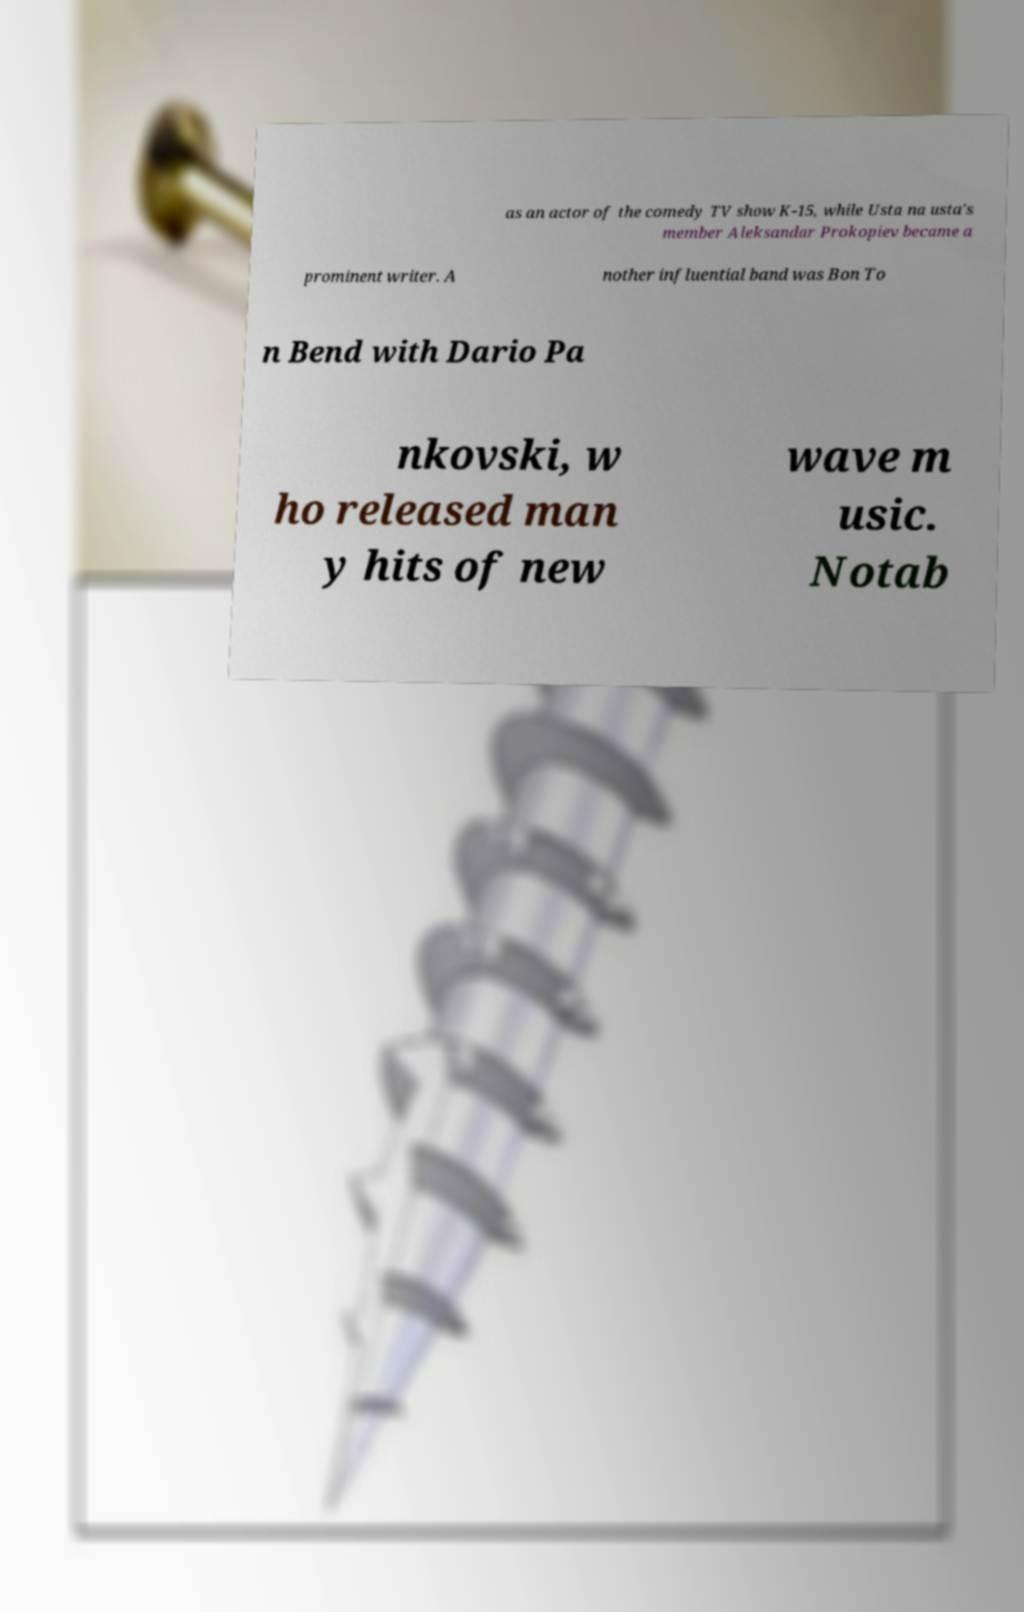There's text embedded in this image that I need extracted. Can you transcribe it verbatim? as an actor of the comedy TV show K-15, while Usta na usta's member Aleksandar Prokopiev became a prominent writer. A nother influential band was Bon To n Bend with Dario Pa nkovski, w ho released man y hits of new wave m usic. Notab 